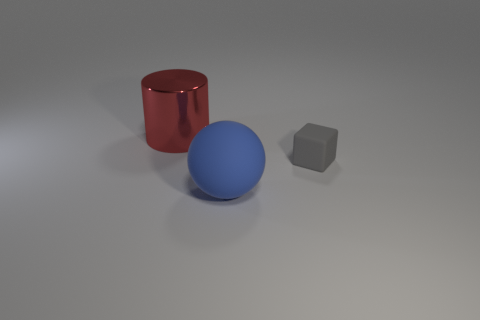Is there anything else that has the same size as the block?
Ensure brevity in your answer.  No. What color is the large object that is on the right side of the red object?
Keep it short and to the point. Blue. What number of metal objects are either blocks or red cylinders?
Your answer should be very brief. 1. What material is the thing that is on the right side of the matte object that is in front of the gray block?
Your response must be concise. Rubber. The cylinder is what color?
Offer a very short reply. Red. There is a large thing in front of the gray object; is there a metallic thing on the right side of it?
Your response must be concise. No. What material is the cylinder?
Provide a succinct answer. Metal. Does the object that is behind the tiny gray rubber thing have the same material as the object that is to the right of the large matte thing?
Provide a succinct answer. No. Are there any other things of the same color as the cube?
Offer a very short reply. No. There is a object that is both in front of the big metal object and on the left side of the matte cube; how big is it?
Your answer should be compact. Large. 